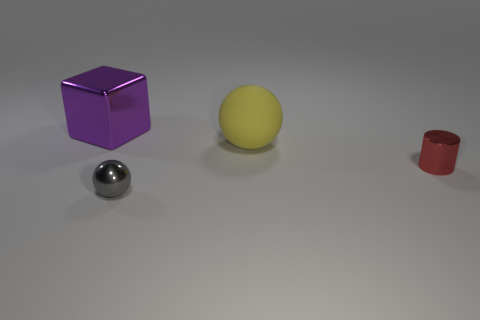What color is the tiny shiny sphere?
Provide a succinct answer. Gray. How many tiny gray things are made of the same material as the red cylinder?
Keep it short and to the point. 1. Is the number of big green cylinders greater than the number of red things?
Provide a short and direct response. No. There is a large object that is in front of the large purple block; how many yellow balls are right of it?
Your response must be concise. 0. How many things are things that are behind the yellow object or tiny cyan matte spheres?
Your response must be concise. 1. Is there a small brown shiny thing of the same shape as the small red thing?
Provide a short and direct response. No. The shiny object on the left side of the small thing to the left of the red metallic cylinder is what shape?
Your response must be concise. Cube. What number of cylinders are either large objects or large red matte objects?
Your answer should be compact. 0. There is a small shiny thing that is right of the large yellow matte ball; does it have the same shape as the large thing that is right of the big purple thing?
Offer a terse response. No. There is a shiny thing that is both behind the small gray metallic object and in front of the purple thing; what is its color?
Offer a terse response. Red. 